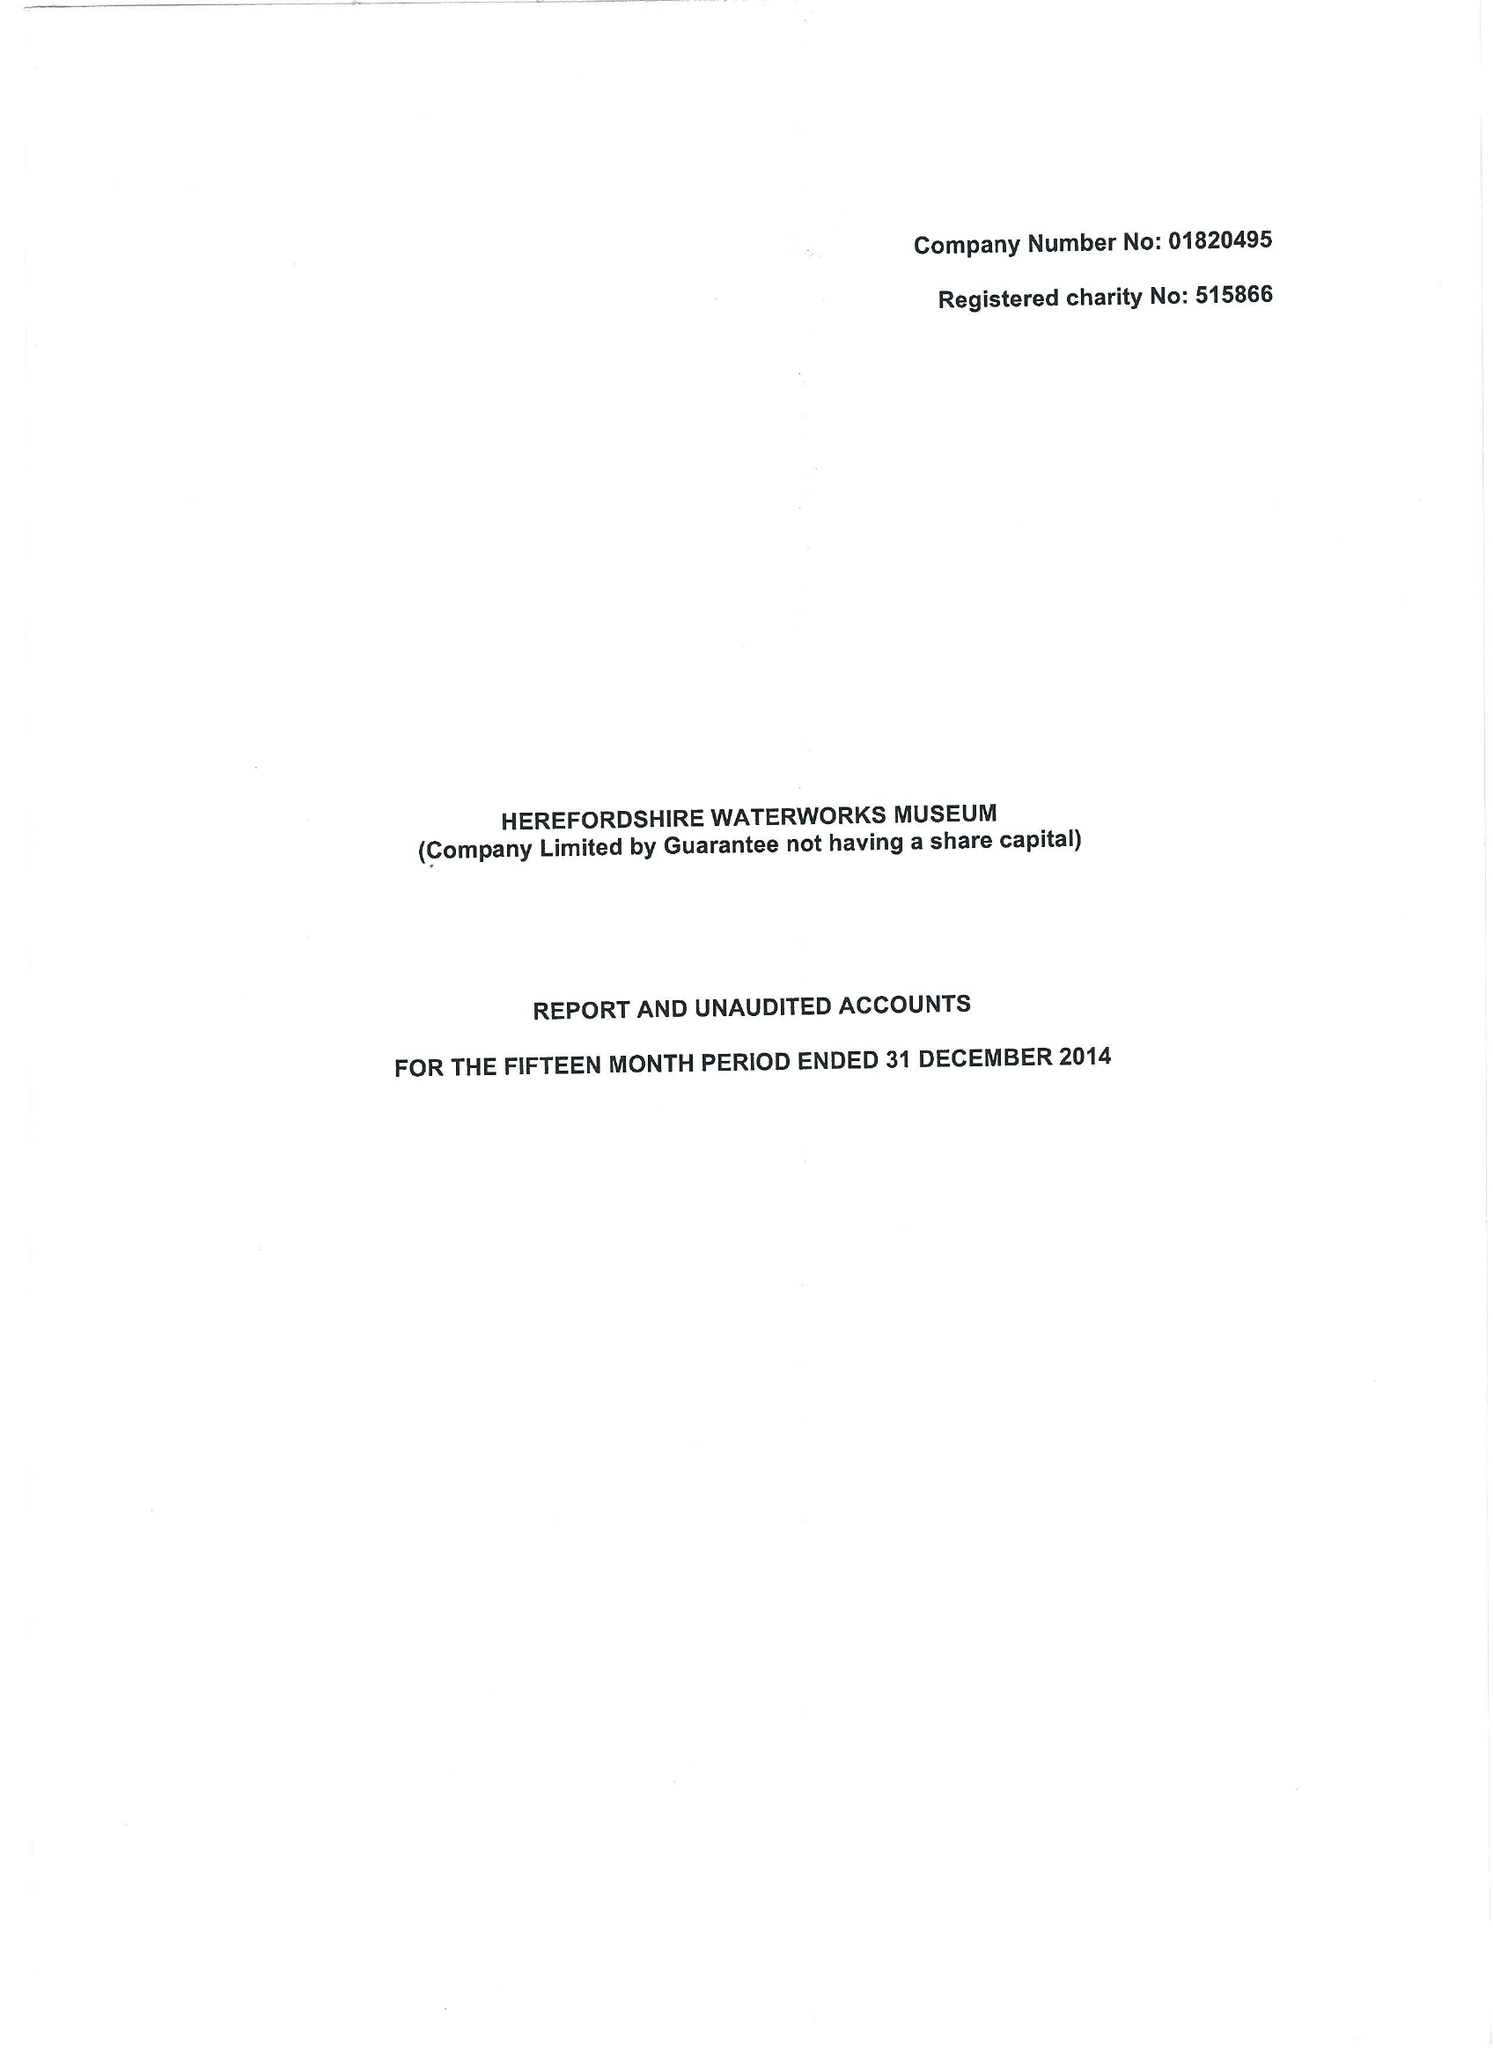What is the value for the address__street_line?
Answer the question using a single word or phrase. BROOMY HILL 